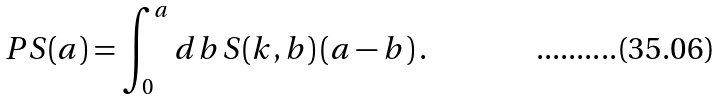<formula> <loc_0><loc_0><loc_500><loc_500>P S ( a ) = \int _ { 0 } ^ { a } d b \, S ( k , b ) \left ( a - b \right ) .</formula> 